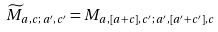<formula> <loc_0><loc_0><loc_500><loc_500>\widetilde { M } _ { a , c ; \, a ^ { \prime } , c ^ { \prime } } = M _ { a , [ a + c ] , c ^ { \prime } ; \, a ^ { \prime } , [ a ^ { \prime } + c ^ { \prime } ] , c }</formula> 